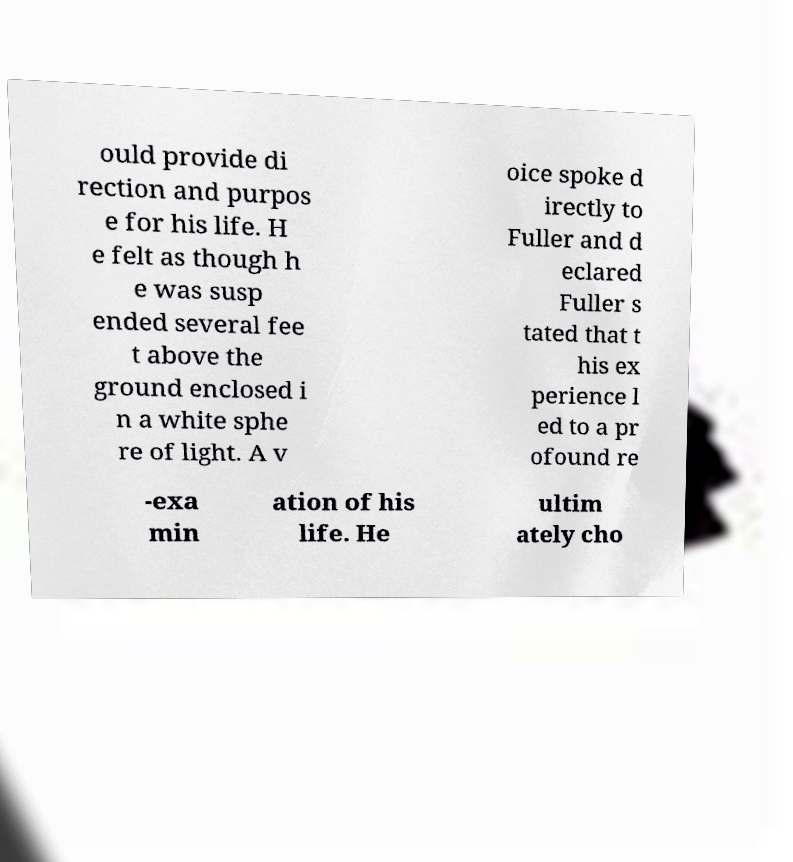What messages or text are displayed in this image? I need them in a readable, typed format. ould provide di rection and purpos e for his life. H e felt as though h e was susp ended several fee t above the ground enclosed i n a white sphe re of light. A v oice spoke d irectly to Fuller and d eclared Fuller s tated that t his ex perience l ed to a pr ofound re -exa min ation of his life. He ultim ately cho 